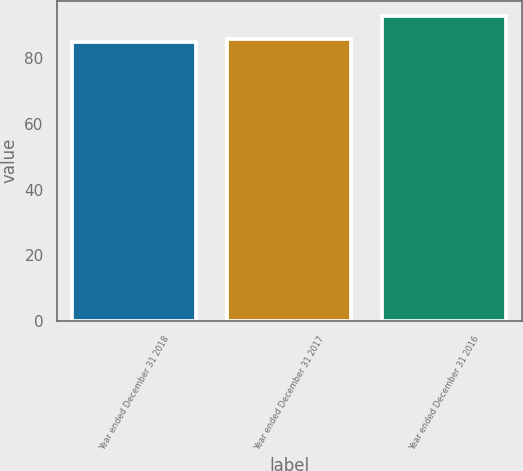<chart> <loc_0><loc_0><loc_500><loc_500><bar_chart><fcel>Year ended December 31 2018<fcel>Year ended December 31 2017<fcel>Year ended December 31 2016<nl><fcel>85<fcel>85.8<fcel>93<nl></chart> 